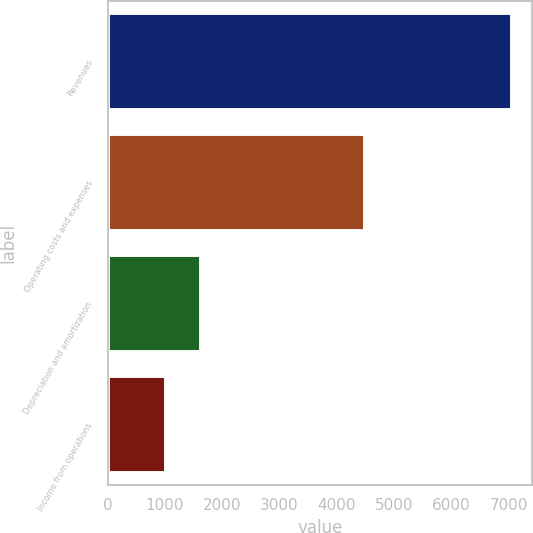Convert chart to OTSL. <chart><loc_0><loc_0><loc_500><loc_500><bar_chart><fcel>Revenues<fcel>Operating costs and expenses<fcel>Depreciation and amortization<fcel>Income from operations<nl><fcel>7059<fcel>4486<fcel>1627.5<fcel>1024<nl></chart> 